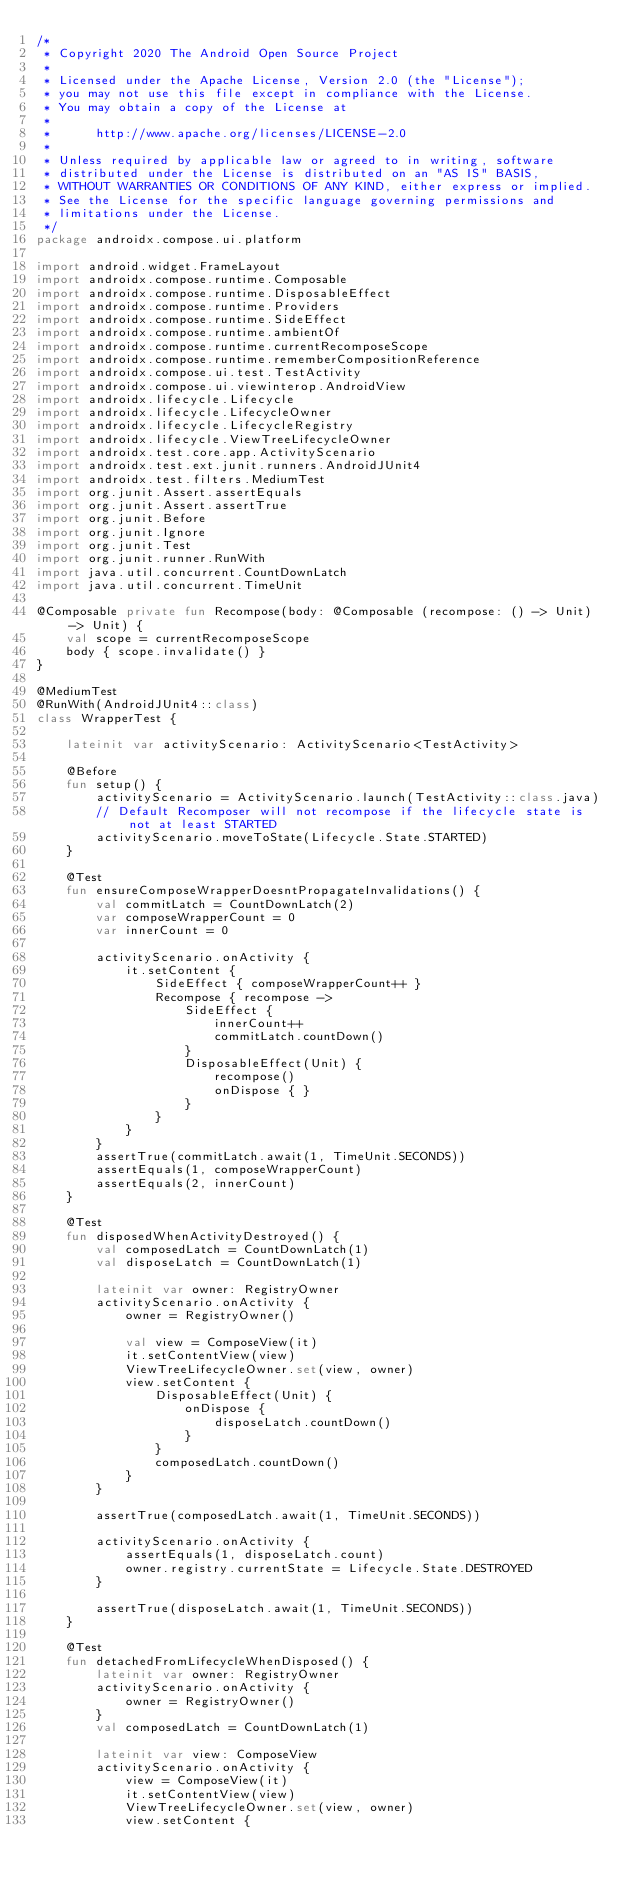<code> <loc_0><loc_0><loc_500><loc_500><_Kotlin_>/*
 * Copyright 2020 The Android Open Source Project
 *
 * Licensed under the Apache License, Version 2.0 (the "License");
 * you may not use this file except in compliance with the License.
 * You may obtain a copy of the License at
 *
 *      http://www.apache.org/licenses/LICENSE-2.0
 *
 * Unless required by applicable law or agreed to in writing, software
 * distributed under the License is distributed on an "AS IS" BASIS,
 * WITHOUT WARRANTIES OR CONDITIONS OF ANY KIND, either express or implied.
 * See the License for the specific language governing permissions and
 * limitations under the License.
 */
package androidx.compose.ui.platform

import android.widget.FrameLayout
import androidx.compose.runtime.Composable
import androidx.compose.runtime.DisposableEffect
import androidx.compose.runtime.Providers
import androidx.compose.runtime.SideEffect
import androidx.compose.runtime.ambientOf
import androidx.compose.runtime.currentRecomposeScope
import androidx.compose.runtime.rememberCompositionReference
import androidx.compose.ui.test.TestActivity
import androidx.compose.ui.viewinterop.AndroidView
import androidx.lifecycle.Lifecycle
import androidx.lifecycle.LifecycleOwner
import androidx.lifecycle.LifecycleRegistry
import androidx.lifecycle.ViewTreeLifecycleOwner
import androidx.test.core.app.ActivityScenario
import androidx.test.ext.junit.runners.AndroidJUnit4
import androidx.test.filters.MediumTest
import org.junit.Assert.assertEquals
import org.junit.Assert.assertTrue
import org.junit.Before
import org.junit.Ignore
import org.junit.Test
import org.junit.runner.RunWith
import java.util.concurrent.CountDownLatch
import java.util.concurrent.TimeUnit

@Composable private fun Recompose(body: @Composable (recompose: () -> Unit) -> Unit) {
    val scope = currentRecomposeScope
    body { scope.invalidate() }
}

@MediumTest
@RunWith(AndroidJUnit4::class)
class WrapperTest {

    lateinit var activityScenario: ActivityScenario<TestActivity>

    @Before
    fun setup() {
        activityScenario = ActivityScenario.launch(TestActivity::class.java)
        // Default Recomposer will not recompose if the lifecycle state is not at least STARTED
        activityScenario.moveToState(Lifecycle.State.STARTED)
    }

    @Test
    fun ensureComposeWrapperDoesntPropagateInvalidations() {
        val commitLatch = CountDownLatch(2)
        var composeWrapperCount = 0
        var innerCount = 0

        activityScenario.onActivity {
            it.setContent {
                SideEffect { composeWrapperCount++ }
                Recompose { recompose ->
                    SideEffect {
                        innerCount++
                        commitLatch.countDown()
                    }
                    DisposableEffect(Unit) {
                        recompose()
                        onDispose { }
                    }
                }
            }
        }
        assertTrue(commitLatch.await(1, TimeUnit.SECONDS))
        assertEquals(1, composeWrapperCount)
        assertEquals(2, innerCount)
    }

    @Test
    fun disposedWhenActivityDestroyed() {
        val composedLatch = CountDownLatch(1)
        val disposeLatch = CountDownLatch(1)

        lateinit var owner: RegistryOwner
        activityScenario.onActivity {
            owner = RegistryOwner()

            val view = ComposeView(it)
            it.setContentView(view)
            ViewTreeLifecycleOwner.set(view, owner)
            view.setContent {
                DisposableEffect(Unit) {
                    onDispose {
                        disposeLatch.countDown()
                    }
                }
                composedLatch.countDown()
            }
        }

        assertTrue(composedLatch.await(1, TimeUnit.SECONDS))

        activityScenario.onActivity {
            assertEquals(1, disposeLatch.count)
            owner.registry.currentState = Lifecycle.State.DESTROYED
        }

        assertTrue(disposeLatch.await(1, TimeUnit.SECONDS))
    }

    @Test
    fun detachedFromLifecycleWhenDisposed() {
        lateinit var owner: RegistryOwner
        activityScenario.onActivity {
            owner = RegistryOwner()
        }
        val composedLatch = CountDownLatch(1)

        lateinit var view: ComposeView
        activityScenario.onActivity {
            view = ComposeView(it)
            it.setContentView(view)
            ViewTreeLifecycleOwner.set(view, owner)
            view.setContent {</code> 